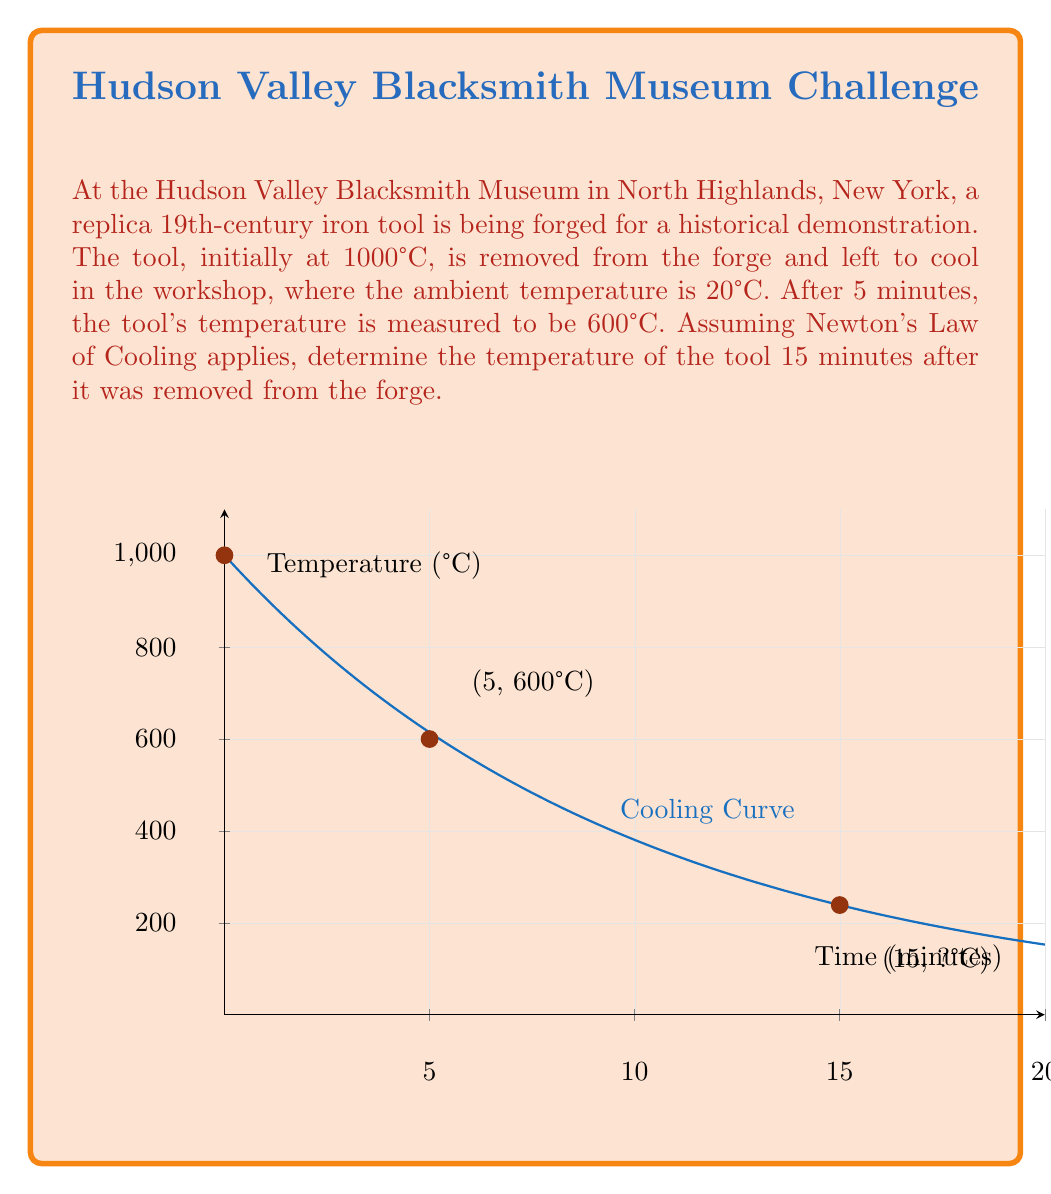Teach me how to tackle this problem. Let's solve this step-by-step using Newton's Law of Cooling:

1) The differential equation for Newton's Law of Cooling is:
   $$\frac{dT}{dt} = -k(T - T_a)$$
   where $T$ is the temperature of the object, $T_a$ is the ambient temperature, $t$ is time, and $k$ is the cooling constant.

2) The solution to this equation is:
   $$T(t) = T_a + (T_0 - T_a)e^{-kt}$$
   where $T_0$ is the initial temperature.

3) We know:
   $T_0 = 1000°C$
   $T_a = 20°C$
   At $t = 5$ minutes, $T = 600°C$

4) Let's substitute these values into the equation:
   $$600 = 20 + (1000 - 20)e^{-5k}$$

5) Simplify:
   $$580 = 980e^{-5k}$$

6) Solve for $k$:
   $$\frac{580}{980} = e^{-5k}$$
   $$\ln(\frac{580}{980}) = -5k$$
   $$k = -\frac{1}{5}\ln(\frac{580}{980}) \approx 0.1$$

7) Now that we have $k$, we can use the original equation to find the temperature at $t = 15$ minutes:
   $$T(15) = 20 + (1000 - 20)e^{-0.1 \cdot 15}$$

8) Calculate:
   $$T(15) = 20 + 980e^{-1.5} \approx 261.4°C$$

Therefore, after 15 minutes, the temperature of the tool will be approximately 261.4°C.
Answer: 261.4°C 